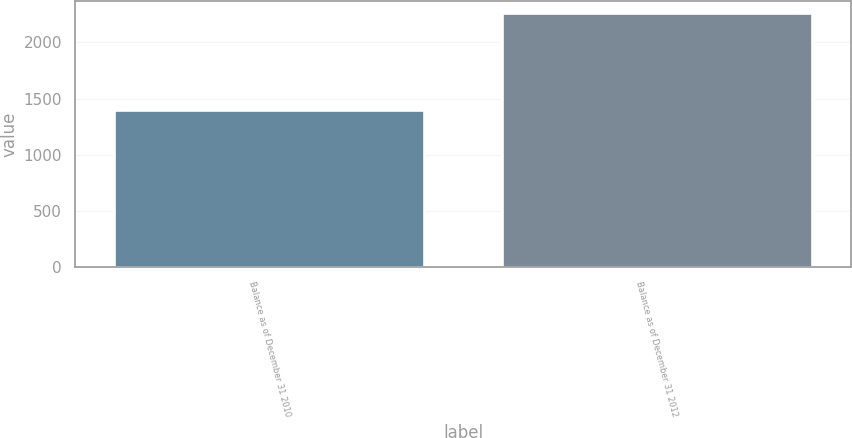Convert chart to OTSL. <chart><loc_0><loc_0><loc_500><loc_500><bar_chart><fcel>Balance as of December 31 2010<fcel>Balance as of December 31 2012<nl><fcel>1402<fcel>2256<nl></chart> 